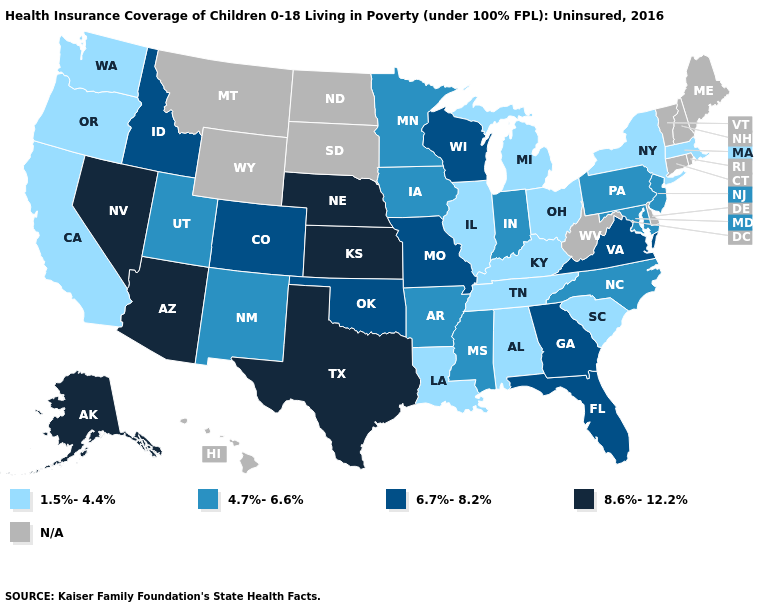Which states hav the highest value in the South?
Concise answer only. Texas. Among the states that border Wisconsin , does Minnesota have the highest value?
Keep it brief. Yes. Among the states that border South Dakota , does Nebraska have the lowest value?
Write a very short answer. No. What is the value of North Dakota?
Give a very brief answer. N/A. What is the lowest value in the USA?
Quick response, please. 1.5%-4.4%. What is the value of Arizona?
Quick response, please. 8.6%-12.2%. Name the states that have a value in the range 1.5%-4.4%?
Quick response, please. Alabama, California, Illinois, Kentucky, Louisiana, Massachusetts, Michigan, New York, Ohio, Oregon, South Carolina, Tennessee, Washington. Name the states that have a value in the range 1.5%-4.4%?
Quick response, please. Alabama, California, Illinois, Kentucky, Louisiana, Massachusetts, Michigan, New York, Ohio, Oregon, South Carolina, Tennessee, Washington. Name the states that have a value in the range 4.7%-6.6%?
Concise answer only. Arkansas, Indiana, Iowa, Maryland, Minnesota, Mississippi, New Jersey, New Mexico, North Carolina, Pennsylvania, Utah. What is the highest value in the South ?
Keep it brief. 8.6%-12.2%. What is the lowest value in states that border Illinois?
Write a very short answer. 1.5%-4.4%. Does New Jersey have the highest value in the Northeast?
Answer briefly. Yes. What is the lowest value in states that border Idaho?
Be succinct. 1.5%-4.4%. What is the lowest value in states that border Washington?
Quick response, please. 1.5%-4.4%. 